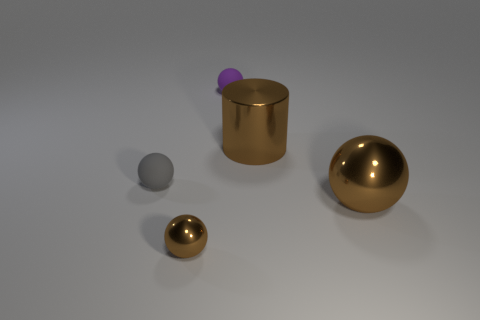Are there the same number of small purple objects that are in front of the tiny brown sphere and purple rubber balls?
Offer a terse response. No. How many large brown things have the same material as the large cylinder?
Provide a succinct answer. 1. What color is the cylinder that is made of the same material as the small brown thing?
Provide a short and direct response. Brown. There is a brown metal cylinder; is it the same size as the brown sphere that is on the left side of the big brown sphere?
Offer a very short reply. No. The purple rubber thing has what shape?
Make the answer very short. Sphere. What number of small metallic things are the same color as the big metal cylinder?
Offer a very short reply. 1. There is a big object that is the same shape as the small brown thing; what is its color?
Provide a short and direct response. Brown. How many metal cylinders are in front of the shiny sphere behind the small brown ball?
Offer a terse response. 0. What number of blocks are large objects or small brown things?
Make the answer very short. 0. Are any metallic cylinders visible?
Offer a terse response. Yes. 